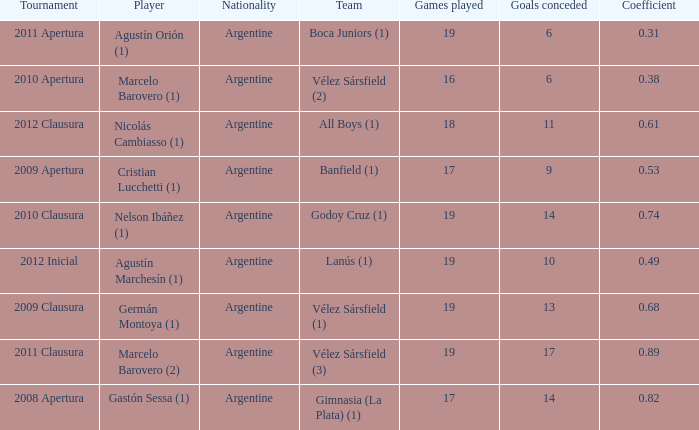Can you parse all the data within this table? {'header': ['Tournament', 'Player', 'Nationality', 'Team', 'Games played', 'Goals conceded', 'Coefficient'], 'rows': [['2011 Apertura', 'Agustín Orión (1)', 'Argentine', 'Boca Juniors (1)', '19', '6', '0.31'], ['2010 Apertura', 'Marcelo Barovero (1)', 'Argentine', 'Vélez Sársfield (2)', '16', '6', '0.38'], ['2012 Clausura', 'Nicolás Cambiasso (1)', 'Argentine', 'All Boys (1)', '18', '11', '0.61'], ['2009 Apertura', 'Cristian Lucchetti (1)', 'Argentine', 'Banfield (1)', '17', '9', '0.53'], ['2010 Clausura', 'Nelson Ibáñez (1)', 'Argentine', 'Godoy Cruz (1)', '19', '14', '0.74'], ['2012 Inicial', 'Agustín Marchesín (1)', 'Argentine', 'Lanús (1)', '19', '10', '0.49'], ['2009 Clausura', 'Germán Montoya (1)', 'Argentine', 'Vélez Sársfield (1)', '19', '13', '0.68'], ['2011 Clausura', 'Marcelo Barovero (2)', 'Argentine', 'Vélez Sársfield (3)', '19', '17', '0.89'], ['2008 Apertura', 'Gastón Sessa (1)', 'Argentine', 'Gimnasia (La Plata) (1)', '17', '14', '0.82']]} What is the nationality of the 2012 clausura  tournament? Argentine. 